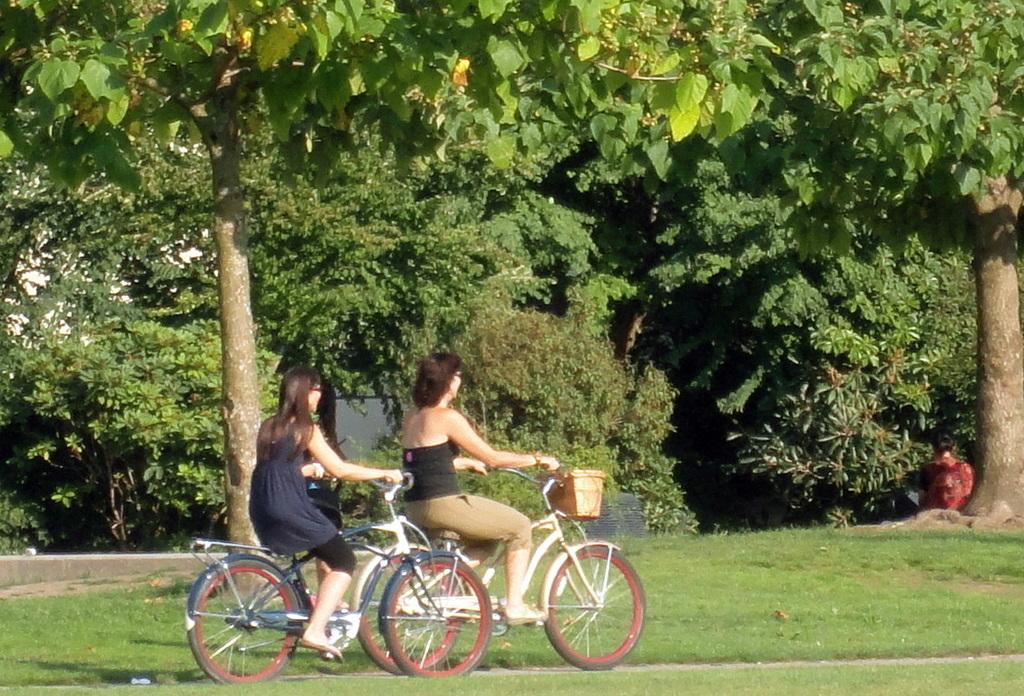How many people are in the image? There are two women in the image. What are the women doing in the image? The women are riding bicycles. What is the surface beneath the bicycles? The bicycles are on fresh green grass. What type of natural environment is visible in the image? There are trees in the image. Can you see any worms crawling on the books in the image? There are no books or worms present in the image. 